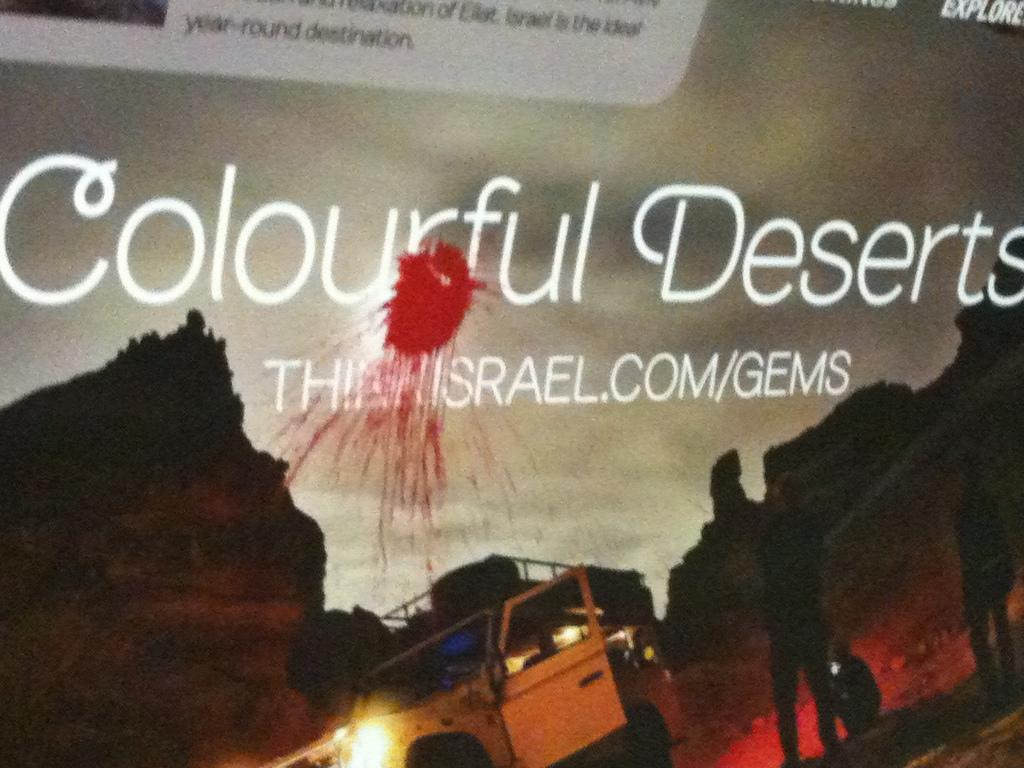Provide a one-sentence caption for the provided image. A billboard of saying "Colourful Deserts" has been vandalized with red pain probably thrown in the balloon. 